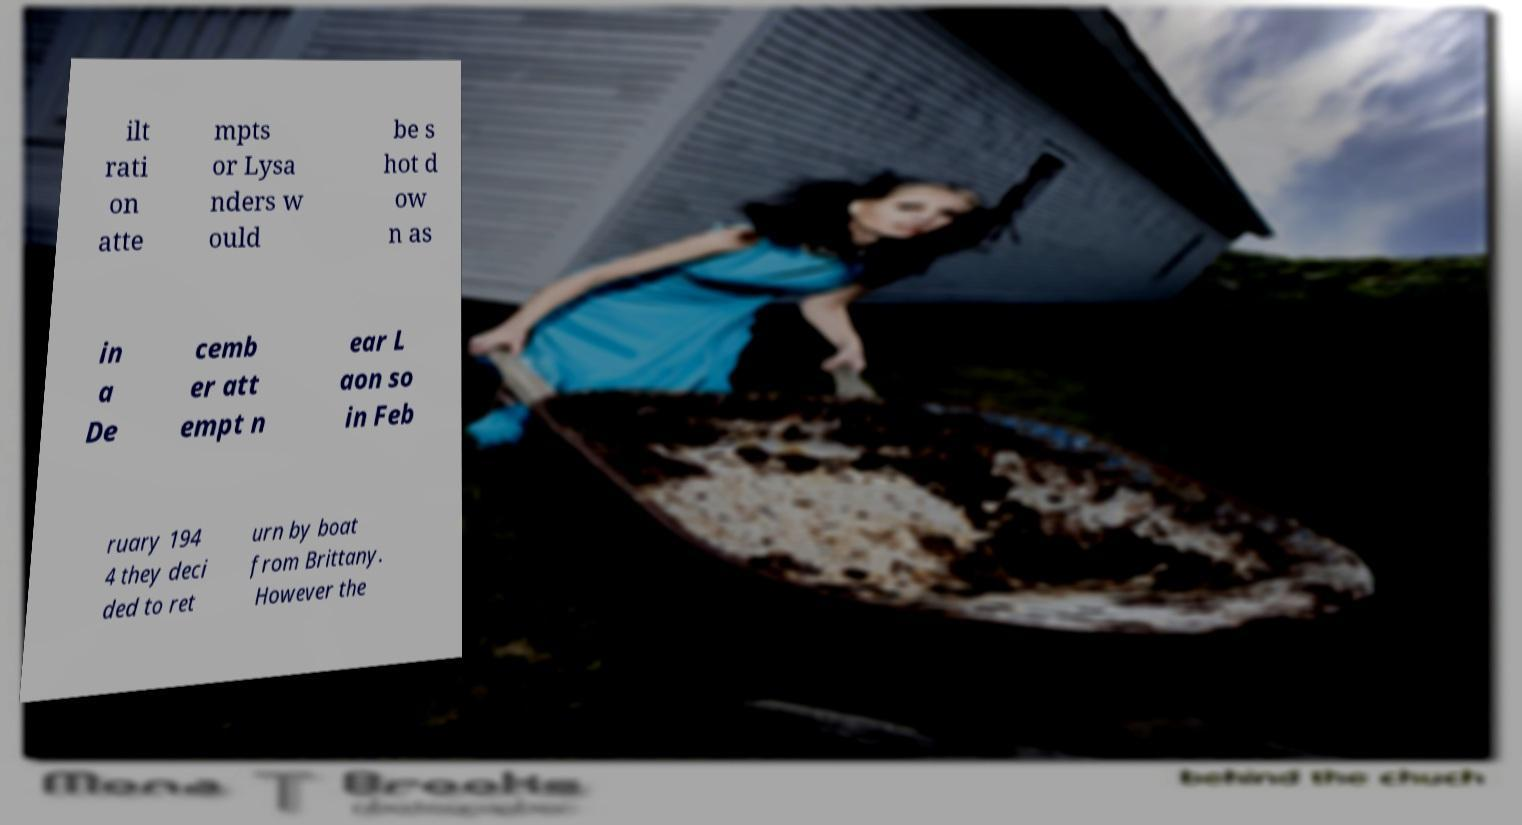Please read and relay the text visible in this image. What does it say? ilt rati on atte mpts or Lysa nders w ould be s hot d ow n as in a De cemb er att empt n ear L aon so in Feb ruary 194 4 they deci ded to ret urn by boat from Brittany. However the 